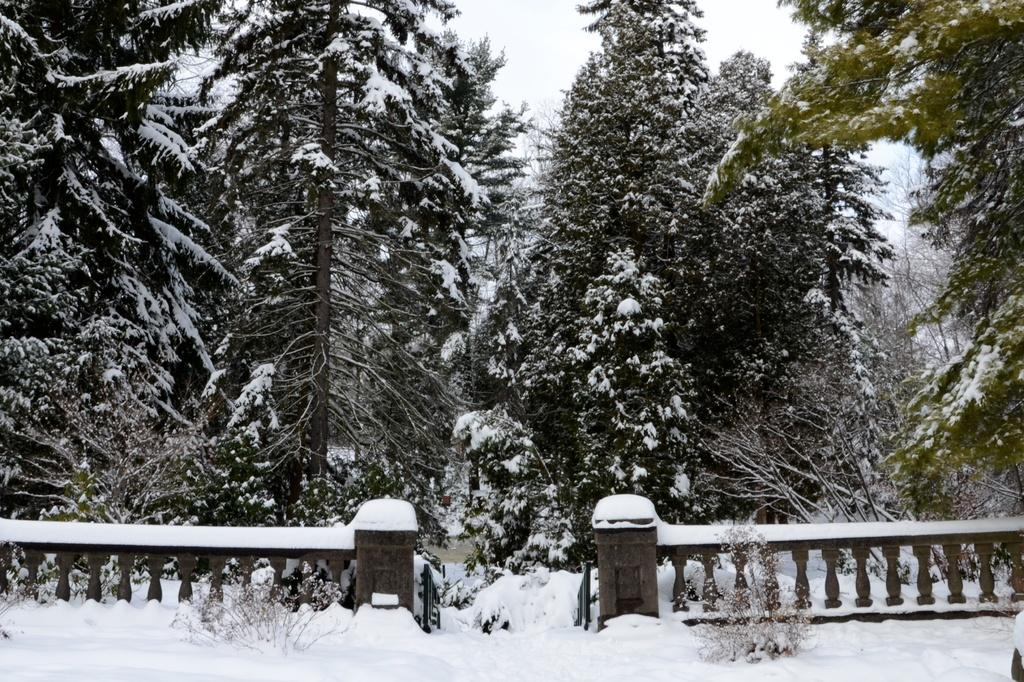What type of structure can be seen in the image? There is a fence in the image. What is the condition of the trees in the image? Trees covered with snow are visible in the image. What is the condition of the road in the image? Snow is present on the road in the image. What can be seen in the background of the image? The sky is visible in the background of the image. Where are the apples located in the image? There are no apples present in the image. Can you describe the lake in the image? There is no lake present in the image. 